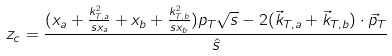<formula> <loc_0><loc_0><loc_500><loc_500>z _ { c } = \frac { ( x _ { a } + \frac { k ^ { 2 } _ { T , a } } { s x _ { a } } + x _ { b } + \frac { k ^ { 2 } _ { T , b } } { s x _ { b } } ) p _ { T } \sqrt { s } - 2 ( \vec { k } _ { T , a } + \vec { k } _ { T , b } ) \cdot \vec { p } _ { T } } { \hat { s } }</formula> 